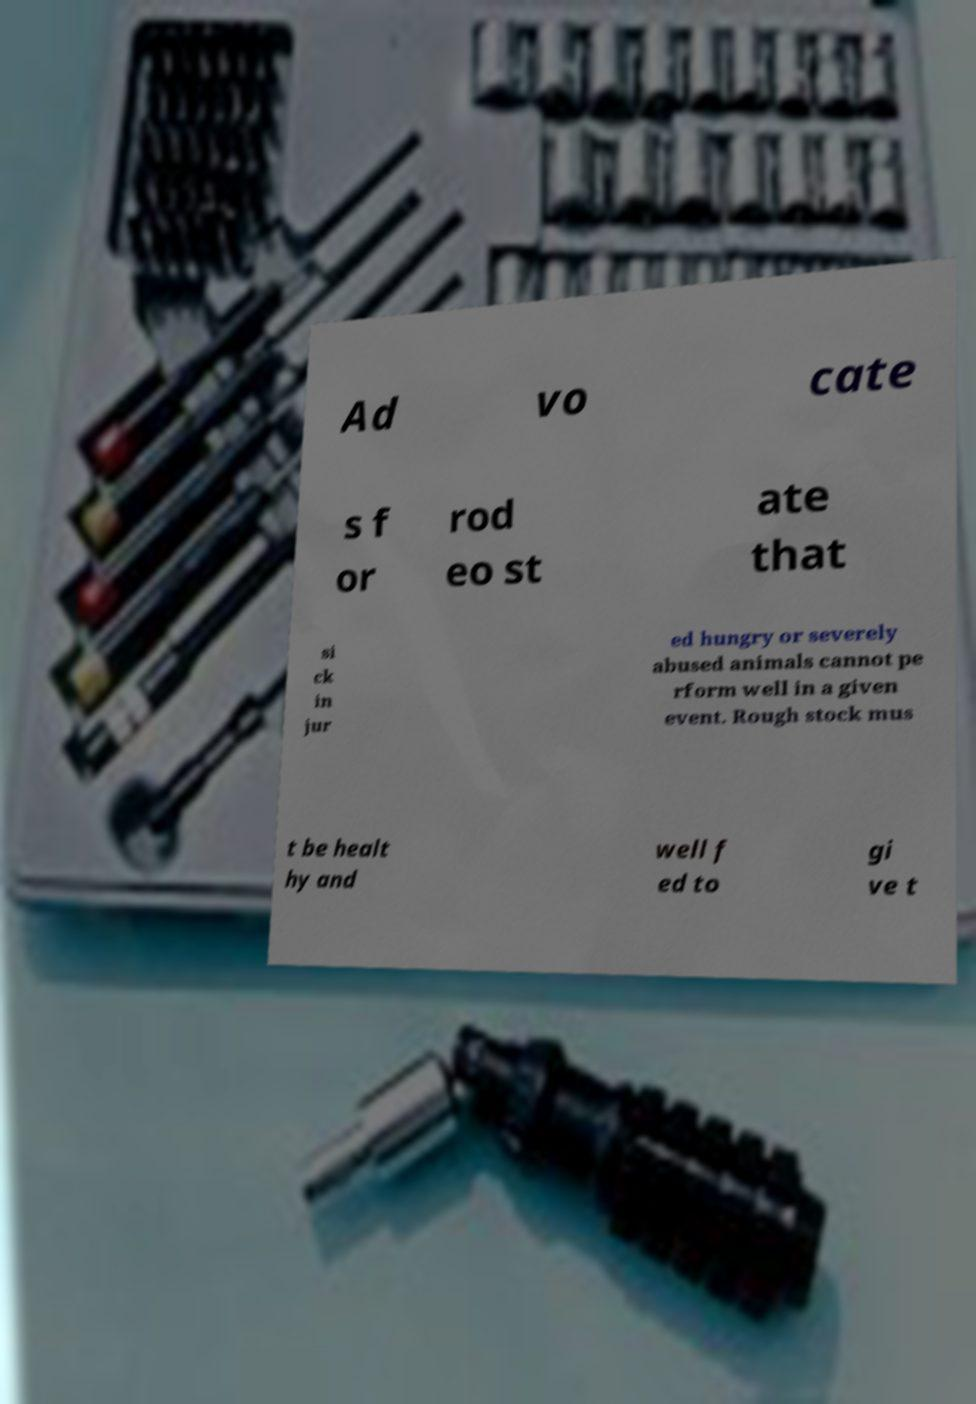I need the written content from this picture converted into text. Can you do that? Ad vo cate s f or rod eo st ate that si ck in jur ed hungry or severely abused animals cannot pe rform well in a given event. Rough stock mus t be healt hy and well f ed to gi ve t 